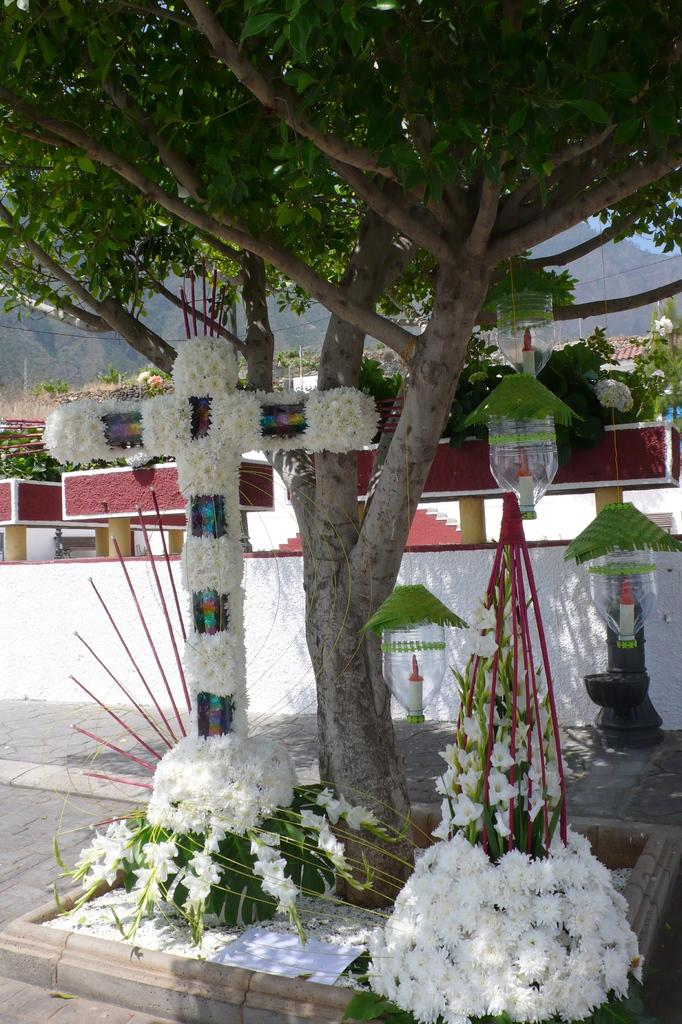What type of plant can be seen in the image? There is a tree in the image. What other natural elements are present in the image? There are flowers and leaves visible in the image. What man-made objects can be seen in the image? There are hanging bottles and a building visible in the image. What can be seen in the distance in the image? There are mountains visible in the background of the image. How does the hat increase the height of the tree in the image? There is no hat present in the image, and therefore no such interaction can be observed. 